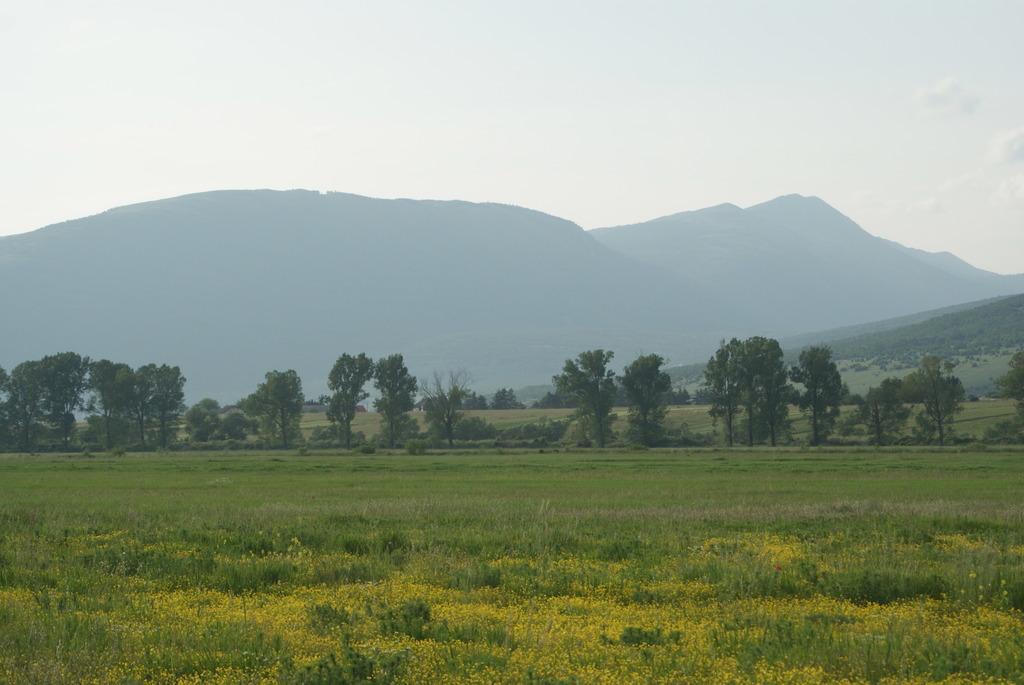In one or two sentences, can you explain what this image depicts? In this picture we can see grass on the ground and in the background we can see trees, mountains and the sky. 